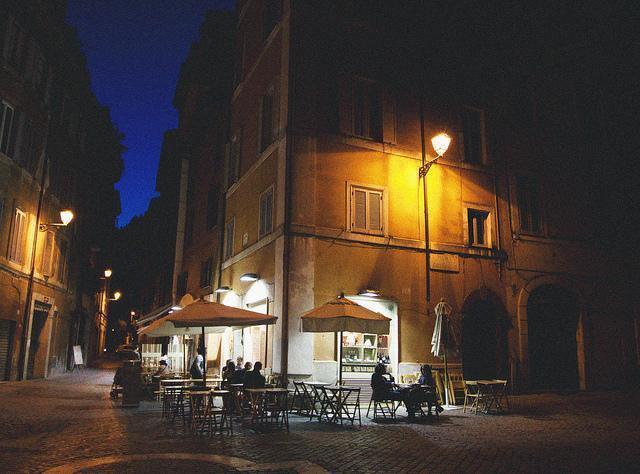How many umbrellas are there?
Give a very brief answer. 2. 